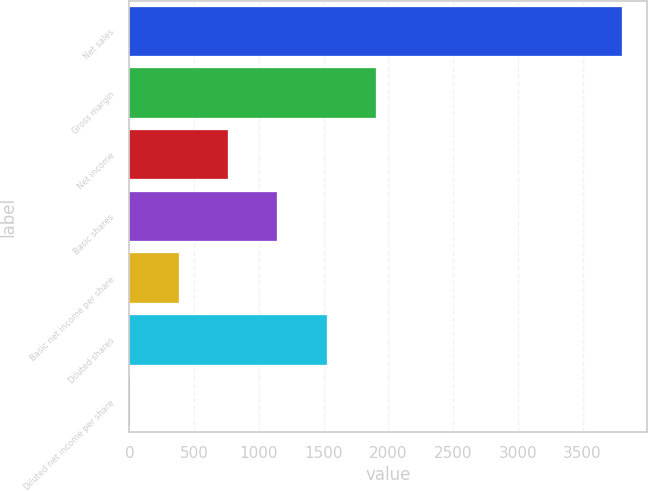<chart> <loc_0><loc_0><loc_500><loc_500><bar_chart><fcel>Net sales<fcel>Gross margin<fcel>Net income<fcel>Basic shares<fcel>Basic net income per share<fcel>Diluted shares<fcel>Diluted net income per share<nl><fcel>3806<fcel>1903.39<fcel>761.81<fcel>1142.34<fcel>381.28<fcel>1522.87<fcel>0.75<nl></chart> 